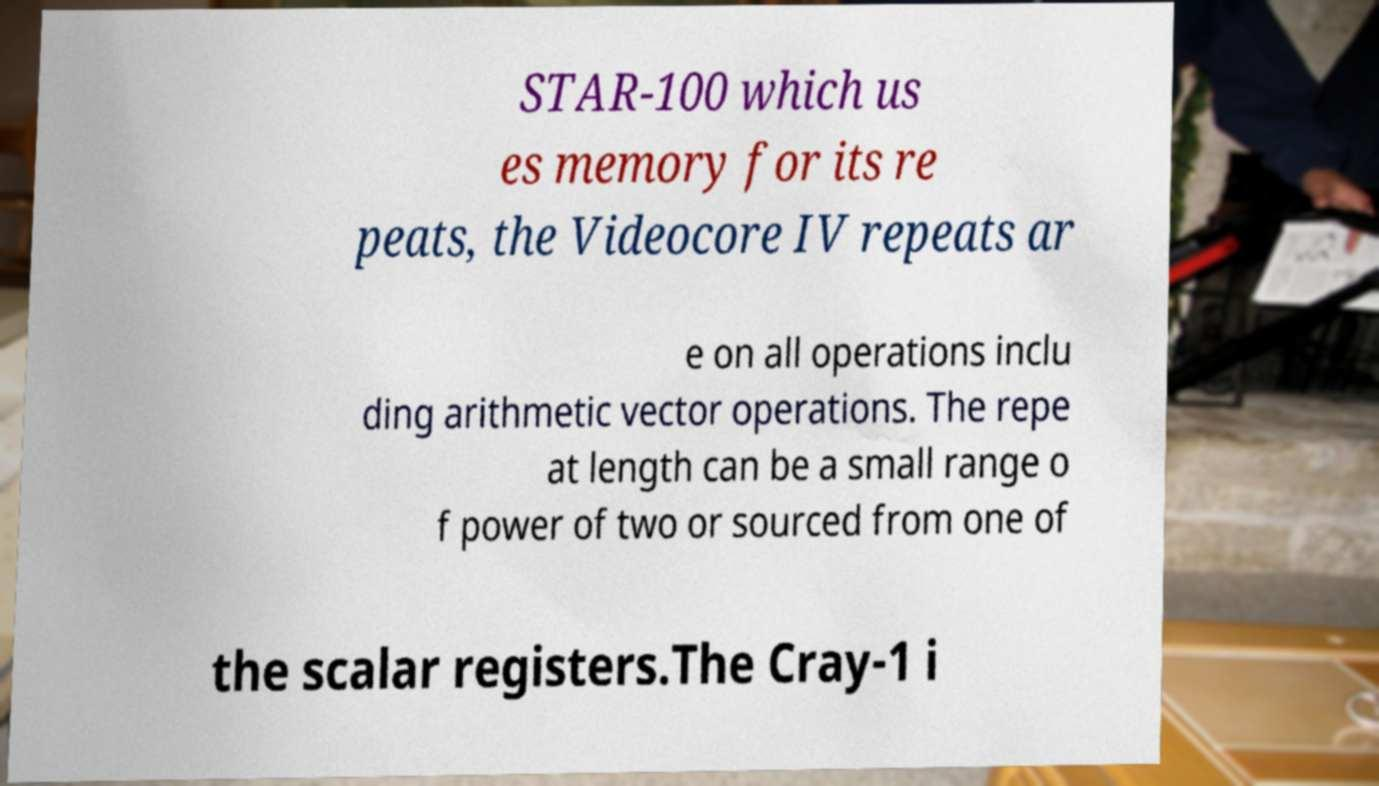Please identify and transcribe the text found in this image. STAR-100 which us es memory for its re peats, the Videocore IV repeats ar e on all operations inclu ding arithmetic vector operations. The repe at length can be a small range o f power of two or sourced from one of the scalar registers.The Cray-1 i 